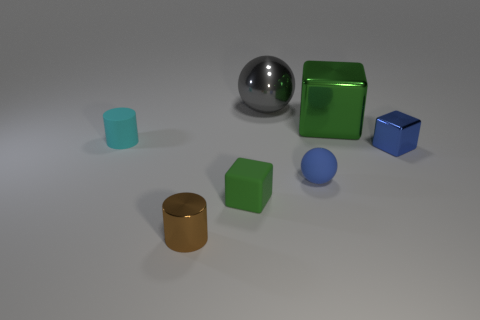Add 3 tiny rubber balls. How many objects exist? 10 Subtract all purple spheres. Subtract all yellow cylinders. How many spheres are left? 2 Subtract all balls. How many objects are left? 5 Add 2 tiny cyan rubber cylinders. How many tiny cyan rubber cylinders are left? 3 Add 4 large cyan matte cylinders. How many large cyan matte cylinders exist? 4 Subtract 0 purple spheres. How many objects are left? 7 Subtract all gray metallic balls. Subtract all large green cubes. How many objects are left? 5 